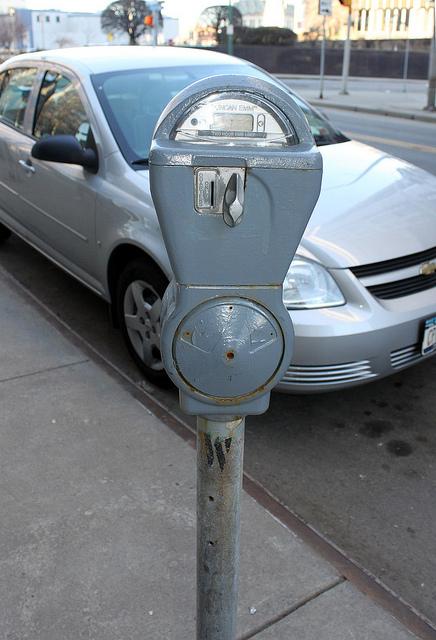What type of car is behind the meter?
Quick response, please. Sedan. What color is the car parked by the meter?
Keep it brief. Silver. How many cars in the picture?
Concise answer only. 1. Can you see rust on the parking meter pole?
Be succinct. Yes. Is there a vehicle parked behind the silver car?
Quick response, please. No. What has left the spots on the pavement in front of the car?
Keep it brief. Oil. Is the parking meter gray?
Concise answer only. Yes. 